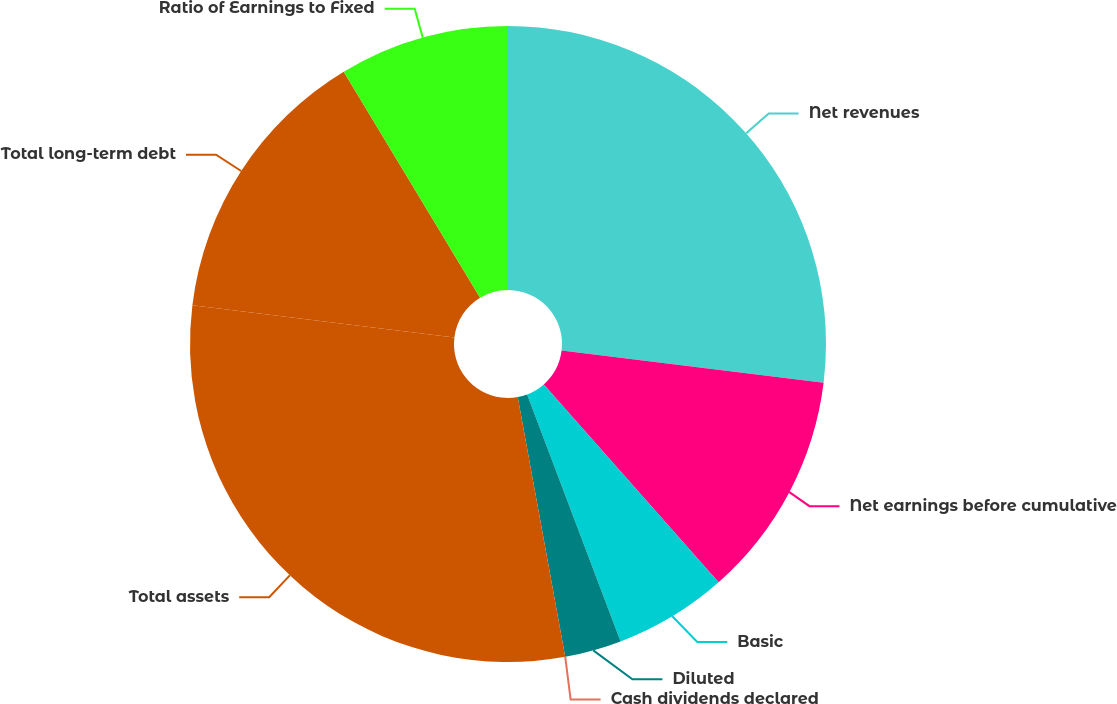Convert chart. <chart><loc_0><loc_0><loc_500><loc_500><pie_chart><fcel>Net revenues<fcel>Net earnings before cumulative<fcel>Basic<fcel>Diluted<fcel>Cash dividends declared<fcel>Total assets<fcel>Total long-term debt<fcel>Ratio of Earnings to Fixed<nl><fcel>26.95%<fcel>11.53%<fcel>5.76%<fcel>2.88%<fcel>0.0%<fcel>29.83%<fcel>14.41%<fcel>8.64%<nl></chart> 